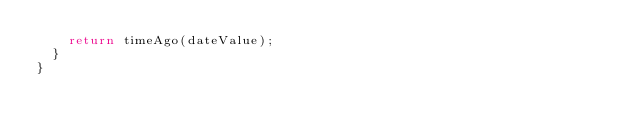Convert code to text. <code><loc_0><loc_0><loc_500><loc_500><_TypeScript_>    return timeAgo(dateValue);
  }
}
</code> 